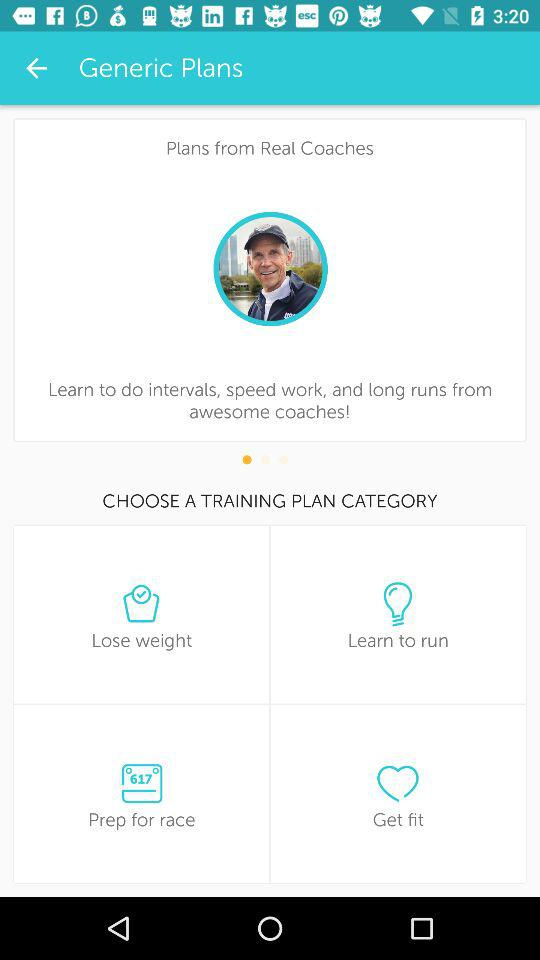What is the name of the application?
When the provided information is insufficient, respond with <no answer>. <no answer> 